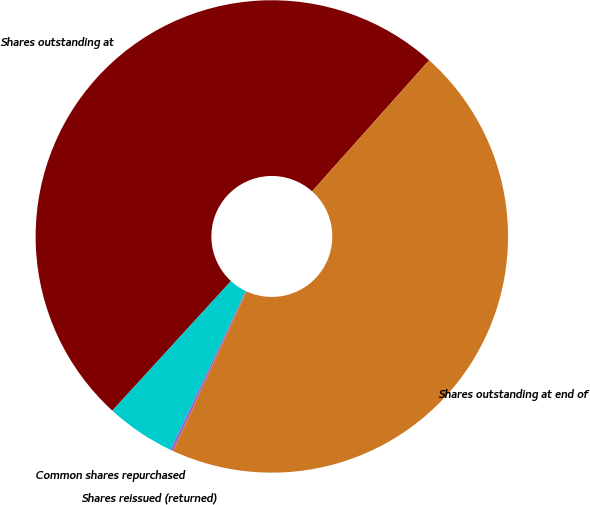Convert chart. <chart><loc_0><loc_0><loc_500><loc_500><pie_chart><fcel>Shares outstanding at<fcel>Common shares repurchased<fcel>Shares reissued (returned)<fcel>Shares outstanding at end of<nl><fcel>49.8%<fcel>4.74%<fcel>0.2%<fcel>45.26%<nl></chart> 